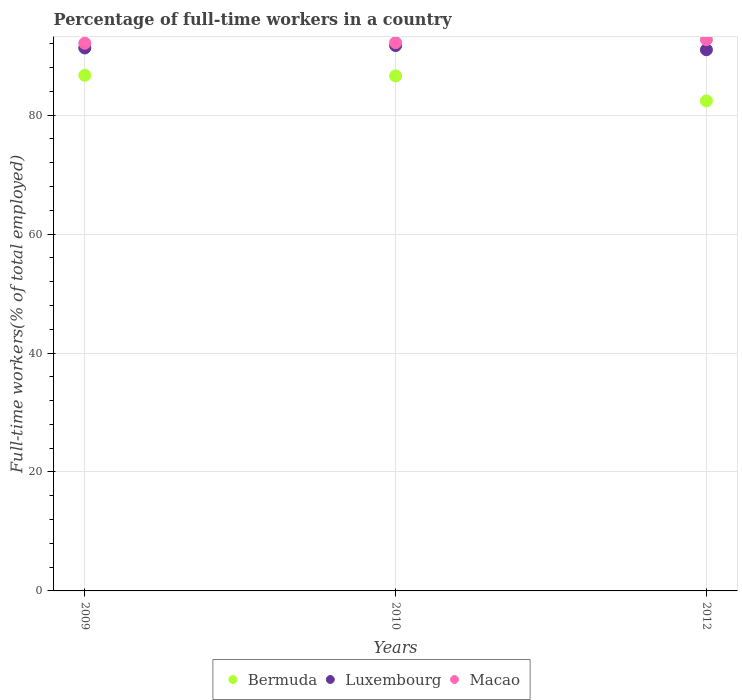How many different coloured dotlines are there?
Provide a succinct answer. 3. Is the number of dotlines equal to the number of legend labels?
Provide a short and direct response. Yes. What is the percentage of full-time workers in Macao in 2009?
Offer a terse response. 92.1. Across all years, what is the maximum percentage of full-time workers in Luxembourg?
Ensure brevity in your answer.  91.7. Across all years, what is the minimum percentage of full-time workers in Macao?
Your answer should be compact. 92.1. In which year was the percentage of full-time workers in Macao minimum?
Make the answer very short. 2009. What is the total percentage of full-time workers in Luxembourg in the graph?
Keep it short and to the point. 274. What is the difference between the percentage of full-time workers in Bermuda in 2010 and that in 2012?
Your response must be concise. 4.2. What is the average percentage of full-time workers in Macao per year?
Provide a succinct answer. 92.33. In the year 2009, what is the difference between the percentage of full-time workers in Macao and percentage of full-time workers in Luxembourg?
Offer a terse response. 0.8. In how many years, is the percentage of full-time workers in Bermuda greater than 76 %?
Offer a terse response. 3. What is the ratio of the percentage of full-time workers in Luxembourg in 2010 to that in 2012?
Provide a succinct answer. 1.01. Is the percentage of full-time workers in Macao in 2010 less than that in 2012?
Your response must be concise. Yes. Is the difference between the percentage of full-time workers in Macao in 2009 and 2012 greater than the difference between the percentage of full-time workers in Luxembourg in 2009 and 2012?
Your answer should be very brief. No. What is the difference between the highest and the second highest percentage of full-time workers in Luxembourg?
Offer a very short reply. 0.4. What is the difference between the highest and the lowest percentage of full-time workers in Bermuda?
Provide a succinct answer. 4.3. Is the percentage of full-time workers in Bermuda strictly less than the percentage of full-time workers in Luxembourg over the years?
Your response must be concise. Yes. What is the difference between two consecutive major ticks on the Y-axis?
Give a very brief answer. 20. What is the title of the graph?
Provide a short and direct response. Percentage of full-time workers in a country. Does "Korea (Republic)" appear as one of the legend labels in the graph?
Provide a succinct answer. No. What is the label or title of the Y-axis?
Provide a succinct answer. Full-time workers(% of total employed). What is the Full-time workers(% of total employed) in Bermuda in 2009?
Give a very brief answer. 86.7. What is the Full-time workers(% of total employed) in Luxembourg in 2009?
Keep it short and to the point. 91.3. What is the Full-time workers(% of total employed) of Macao in 2009?
Provide a short and direct response. 92.1. What is the Full-time workers(% of total employed) in Bermuda in 2010?
Your answer should be compact. 86.6. What is the Full-time workers(% of total employed) of Luxembourg in 2010?
Keep it short and to the point. 91.7. What is the Full-time workers(% of total employed) of Macao in 2010?
Offer a very short reply. 92.2. What is the Full-time workers(% of total employed) of Bermuda in 2012?
Provide a succinct answer. 82.4. What is the Full-time workers(% of total employed) in Luxembourg in 2012?
Ensure brevity in your answer.  91. What is the Full-time workers(% of total employed) in Macao in 2012?
Offer a very short reply. 92.7. Across all years, what is the maximum Full-time workers(% of total employed) in Bermuda?
Provide a short and direct response. 86.7. Across all years, what is the maximum Full-time workers(% of total employed) of Luxembourg?
Keep it short and to the point. 91.7. Across all years, what is the maximum Full-time workers(% of total employed) of Macao?
Ensure brevity in your answer.  92.7. Across all years, what is the minimum Full-time workers(% of total employed) in Bermuda?
Keep it short and to the point. 82.4. Across all years, what is the minimum Full-time workers(% of total employed) of Luxembourg?
Provide a short and direct response. 91. Across all years, what is the minimum Full-time workers(% of total employed) in Macao?
Give a very brief answer. 92.1. What is the total Full-time workers(% of total employed) of Bermuda in the graph?
Your answer should be very brief. 255.7. What is the total Full-time workers(% of total employed) in Luxembourg in the graph?
Make the answer very short. 274. What is the total Full-time workers(% of total employed) in Macao in the graph?
Provide a succinct answer. 277. What is the difference between the Full-time workers(% of total employed) of Bermuda in 2009 and that in 2012?
Ensure brevity in your answer.  4.3. What is the difference between the Full-time workers(% of total employed) in Macao in 2009 and that in 2012?
Offer a terse response. -0.6. What is the difference between the Full-time workers(% of total employed) of Bermuda in 2009 and the Full-time workers(% of total employed) of Luxembourg in 2010?
Your answer should be compact. -5. What is the difference between the Full-time workers(% of total employed) in Bermuda in 2009 and the Full-time workers(% of total employed) in Luxembourg in 2012?
Your answer should be very brief. -4.3. What is the difference between the Full-time workers(% of total employed) in Bermuda in 2009 and the Full-time workers(% of total employed) in Macao in 2012?
Your answer should be compact. -6. What is the difference between the Full-time workers(% of total employed) in Bermuda in 2010 and the Full-time workers(% of total employed) in Luxembourg in 2012?
Offer a very short reply. -4.4. What is the difference between the Full-time workers(% of total employed) in Luxembourg in 2010 and the Full-time workers(% of total employed) in Macao in 2012?
Offer a very short reply. -1. What is the average Full-time workers(% of total employed) in Bermuda per year?
Make the answer very short. 85.23. What is the average Full-time workers(% of total employed) in Luxembourg per year?
Make the answer very short. 91.33. What is the average Full-time workers(% of total employed) in Macao per year?
Make the answer very short. 92.33. In the year 2009, what is the difference between the Full-time workers(% of total employed) of Bermuda and Full-time workers(% of total employed) of Luxembourg?
Make the answer very short. -4.6. In the year 2009, what is the difference between the Full-time workers(% of total employed) of Bermuda and Full-time workers(% of total employed) of Macao?
Your response must be concise. -5.4. In the year 2009, what is the difference between the Full-time workers(% of total employed) in Luxembourg and Full-time workers(% of total employed) in Macao?
Make the answer very short. -0.8. In the year 2012, what is the difference between the Full-time workers(% of total employed) in Bermuda and Full-time workers(% of total employed) in Luxembourg?
Your response must be concise. -8.6. In the year 2012, what is the difference between the Full-time workers(% of total employed) in Bermuda and Full-time workers(% of total employed) in Macao?
Offer a terse response. -10.3. In the year 2012, what is the difference between the Full-time workers(% of total employed) of Luxembourg and Full-time workers(% of total employed) of Macao?
Provide a short and direct response. -1.7. What is the ratio of the Full-time workers(% of total employed) in Bermuda in 2009 to that in 2012?
Your response must be concise. 1.05. What is the ratio of the Full-time workers(% of total employed) of Luxembourg in 2009 to that in 2012?
Your answer should be very brief. 1. What is the ratio of the Full-time workers(% of total employed) in Bermuda in 2010 to that in 2012?
Your response must be concise. 1.05. What is the ratio of the Full-time workers(% of total employed) in Luxembourg in 2010 to that in 2012?
Your response must be concise. 1.01. What is the difference between the highest and the second highest Full-time workers(% of total employed) of Luxembourg?
Your answer should be compact. 0.4. What is the difference between the highest and the lowest Full-time workers(% of total employed) of Luxembourg?
Your response must be concise. 0.7. What is the difference between the highest and the lowest Full-time workers(% of total employed) of Macao?
Keep it short and to the point. 0.6. 